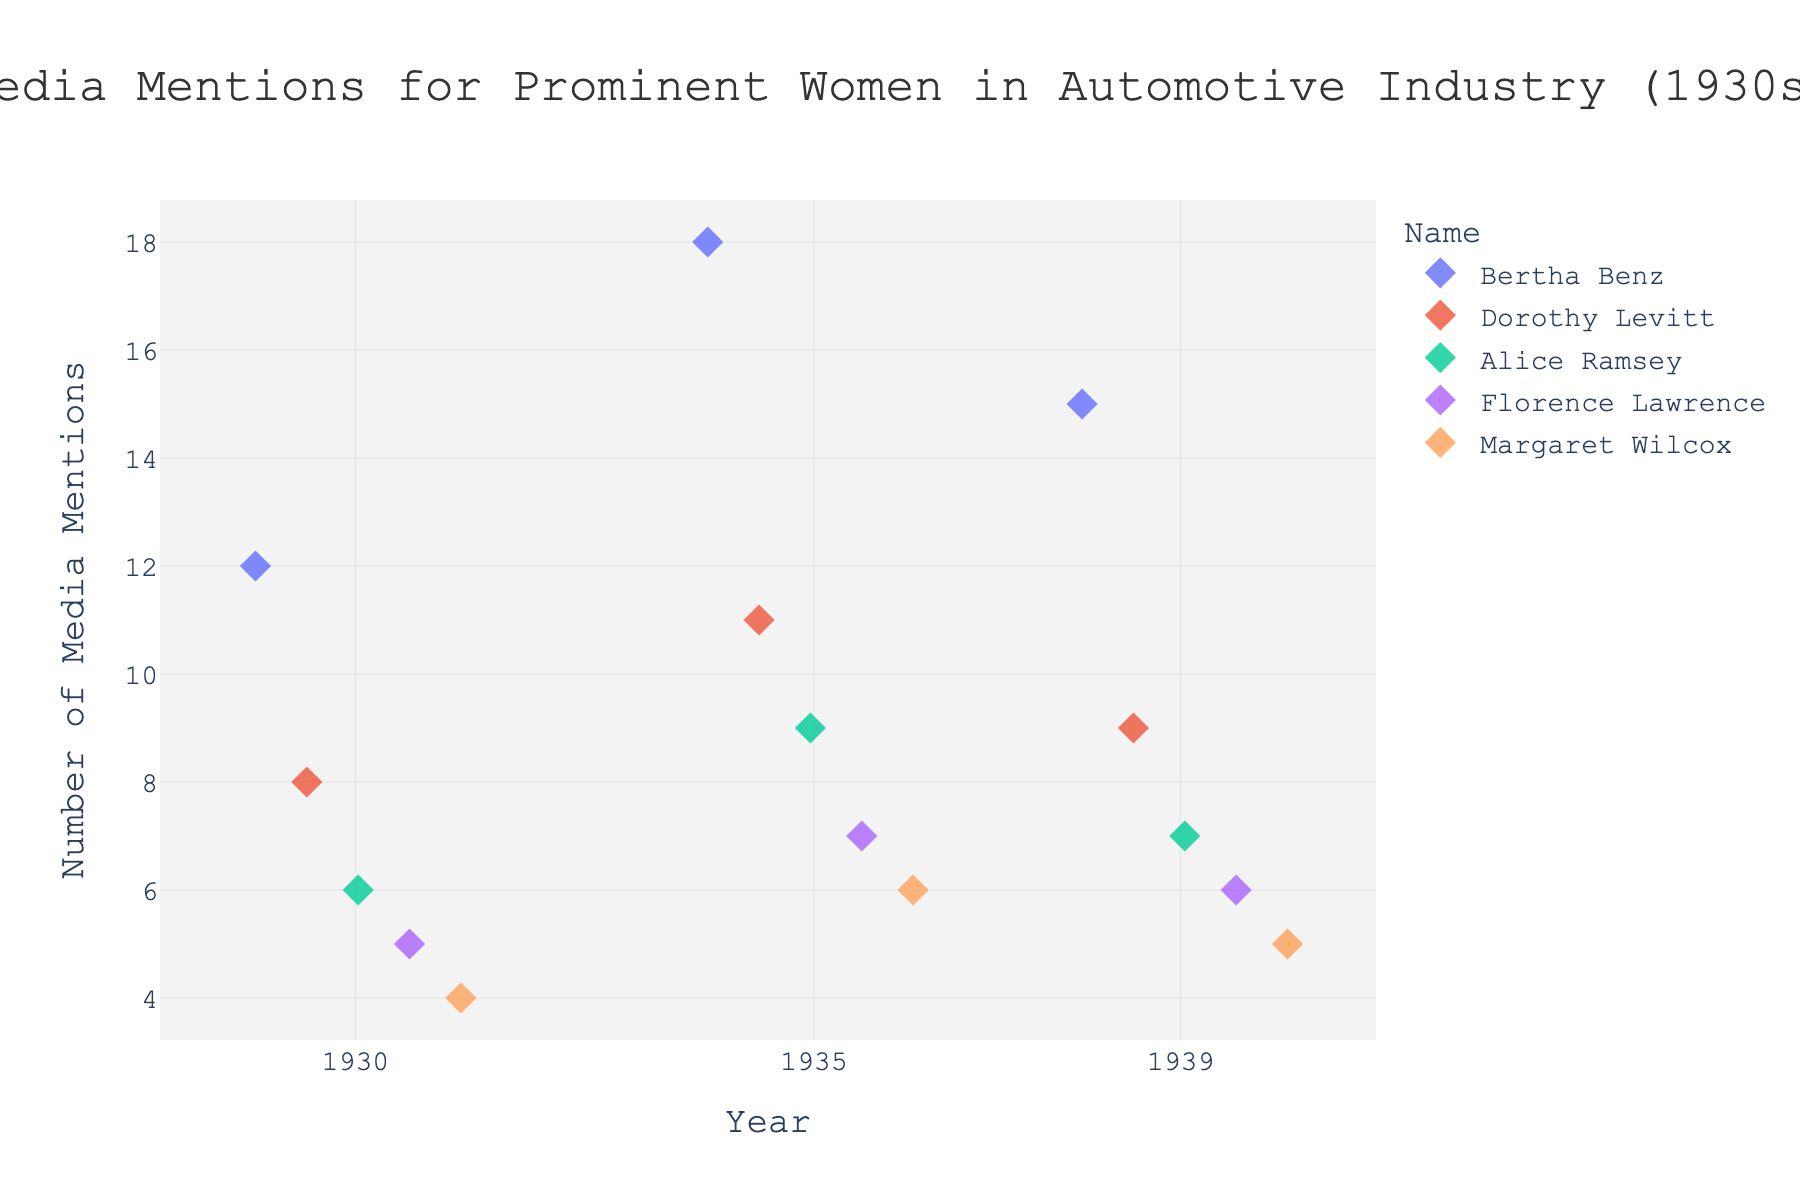What is the title of the figure? The title of the figure can be found at the top center of the plot. It reads "Media Mentions for Prominent Women in Automotive Industry (1930s)"
Answer: Media Mentions for Prominent Women in Automotive Industry (1930s) How many years are displayed on the x-axis? The x-axis shows three distinct years, which are represented as ticks for the years 1930, 1935, and 1939
Answer: 3 Who received the highest number of media mentions in 1935? Looking at the vertical alignment of points above 1935, Bertha Benz has the highest point at 18 media mentions
Answer: Bertha Benz Which woman had the lowest number of media mentions in 1930? For the year 1930, the point with the lowest y-value corresponds to Margaret Wilcox, who had 4 media mentions
Answer: Margaret Wilcox Was there any year where Florence Lawrence had more media mentions than Dorothy Levitt? Comparing the values for Florence Lawrence and Dorothy Levitt across each of the years, there is no year where Florence Lawrence had more mentions. Dorothy consistently has higher mentions
Answer: No Calculate the change in media mentions for Alice Ramsey from 1930 to 1939. In 1930, Alice Ramsey had 6 media mentions and in 1939, she had 7. The difference is 7 - 6 = 1
Answer: 1 Which two women had a tie in the number of media mentions in 1939? By examining the points above 1939, it is seen that both Florence Lawrence and Margaret Wilcox had 6 and 5 mentions respectively. Since "tie" concerns an equal number, they aren't tied. Double-checks confirm this. However, no two women had the same number of mentions in 1939.
Answer: None What is the median value of media mentions in 1935 for the women listed? Arranging the mentions for 1935: 6 (Margaret Wilcox), 7 (Florence Lawrence), 9 (Alice Ramsey), 11 (Dorothy Levitt), and 18 (Bertha Benz). The median value is 9
Answer: 9 Is there a trend in media mentions for Bertha Benz from 1930 to 1939? Observing Bertha Benz’s points: 12 in 1930, 18 in 1935, and 15 in 1939, the trend starts with an increase (12 to 18) and then a slight decrease (18 to 15) towards 1939. This suggests a non-linear trend
Answer: Increase then decrease 